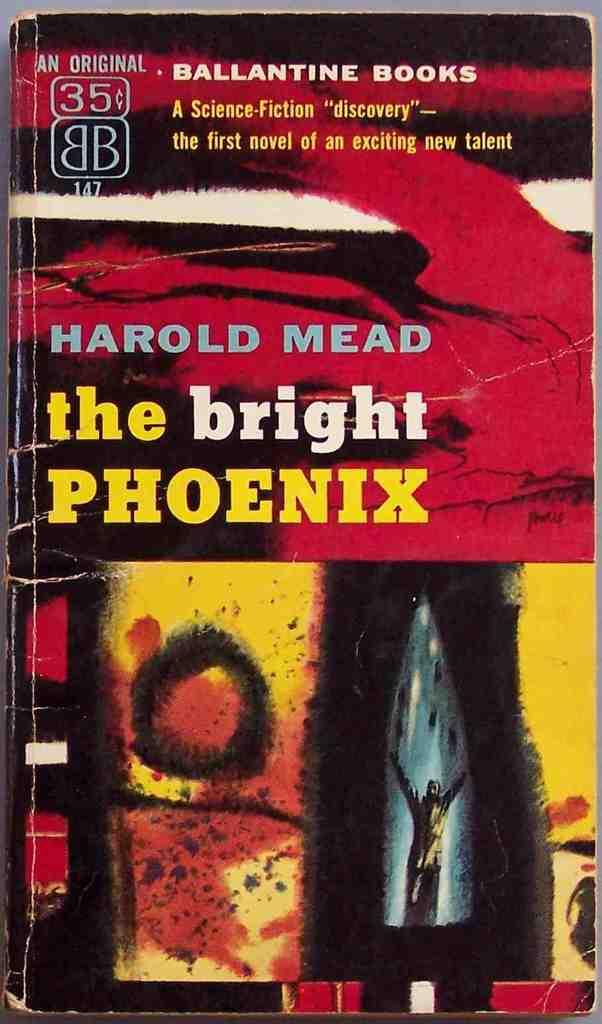What genre is this book?
Provide a short and direct response. Science fiction. What is this book about?
Offer a terse response. The bright phoenix. 